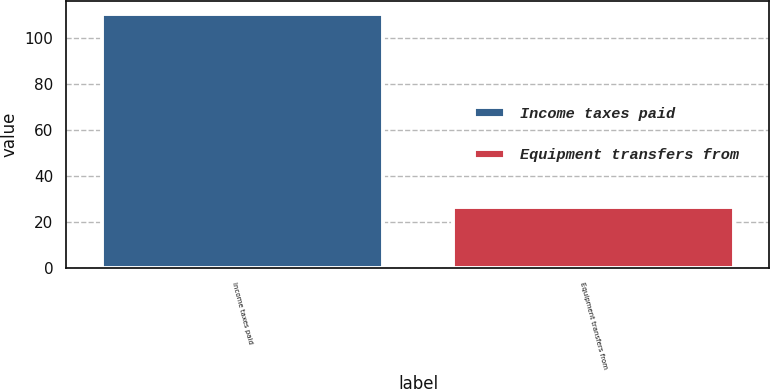<chart> <loc_0><loc_0><loc_500><loc_500><bar_chart><fcel>Income taxes paid<fcel>Equipment transfers from<nl><fcel>110.3<fcel>26.7<nl></chart> 